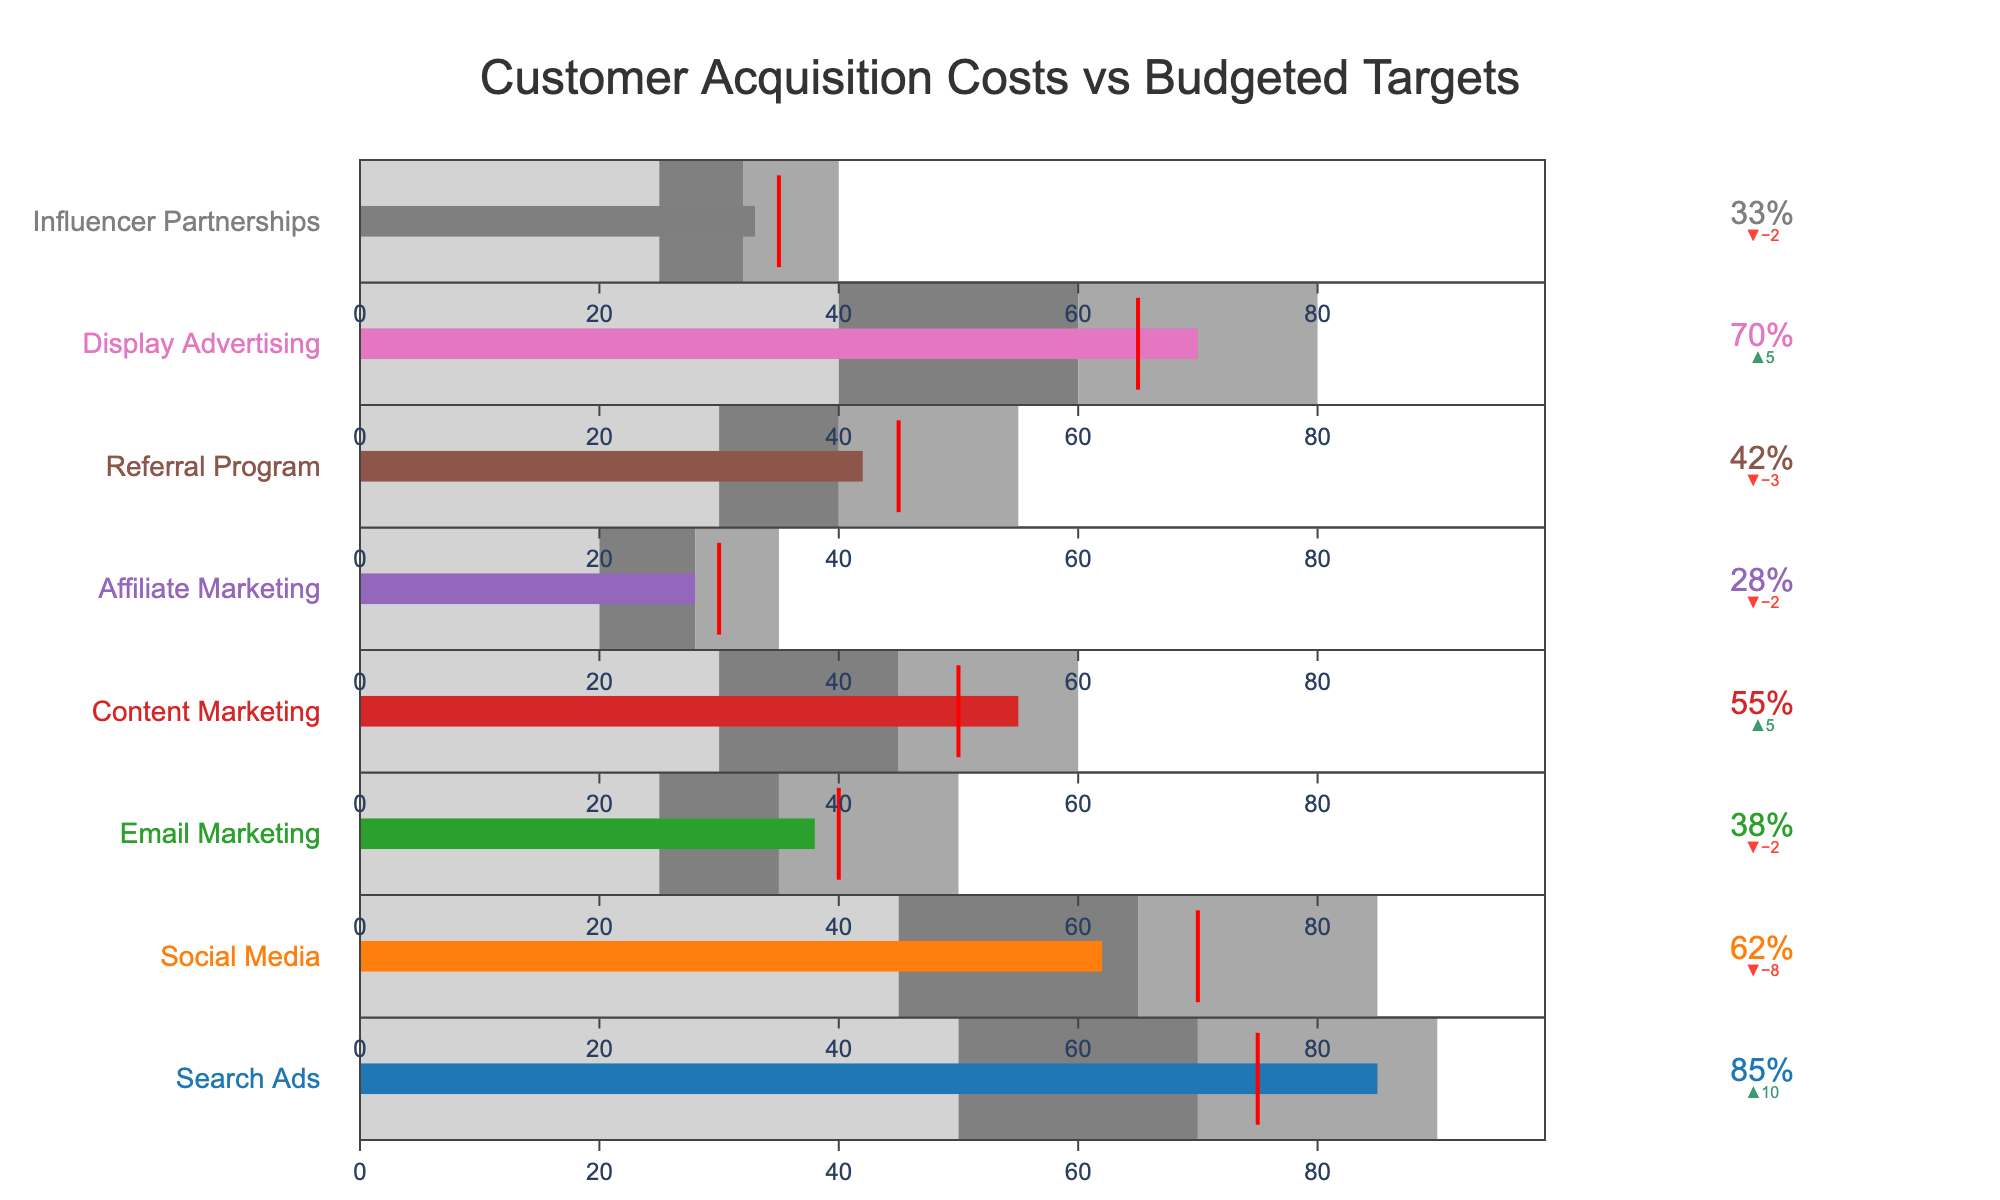What's the title of the figure? The title of the figure is positioned at the top and it reads "Customer Acquisition Costs vs Budgeted Targets".
Answer: Customer Acquisition Costs vs Budgeted Targets How many marketing channels are represented in the figure? The figure lists each marketing channel along the vertical axis, and counting these we get a total of 8 marketing channels.
Answer: 8 Which marketing channel has the highest actual customer acquisition cost? By visually inspecting the lengths of the bars in the bullet chart, "Search Ads" has the highest actual cost, indicated by the longest bar.
Answer: Search Ads Is the actual cost for "Email Marketing" above or below its target? The actual cost for "Email Marketing" is 38, which is shown by its bar. The target cost, indicated by a red line, is 40. Since 38 is less than 40, the actual cost is below its target.
Answer: Below What is the difference between the actual and target costs for "Referral Program"? The actual cost for "Referral Program" is 42 and its target cost is 45. The difference is calculated as 45 - 42.
Answer: 3 Does "Social Media" have an actual cost that falls within its range 2 band? Range 2 for "Social Media" is from 45 to 65. The actual cost is 62, which falls within this range.
Answer: Yes Which channel has the biggest gap between the actual cost and the target cost? To find this, you compare the difference between actual and target costs for each channel. "Search Ads" has an actual cost of 85 and a target of 75, giving a gap of 10, which is the largest compared to others.
Answer: Search Ads How does the actual cost of "Content Marketing" compare to its range 3 upper limit? The actual cost for "Content Marketing" is 55, and the upper limit of range 3 is 60. Since 55 is less than 60, the actual cost is within the range 3 limit.
Answer: Within Which channels have their actual costs within their target thresholds? To find channels that have actual costs within their target, you look for bars that do not exceed the target line (indicated as a red line). These channels are "Email Marketing", "Content Marketing", "Affiliate Marketing", "Referral Program", and "Influencer Partnerships".
Answer: Email Marketing, Content Marketing, Affiliate Marketing, Referral Program, Influencer Partnerships For "Display Advertising", is the actual cost closer to the lower or upper end of its range 3 band? The range 3 band for "Display Advertising" is from 60 to 80. The actual cost is 70. The proximity to the lower end is calculated as 70 - 60 = 10 and to the upper end as 80 - 70 = 10. Since both values are equal, it is equidistant from both ends.
Answer: Equidistant 